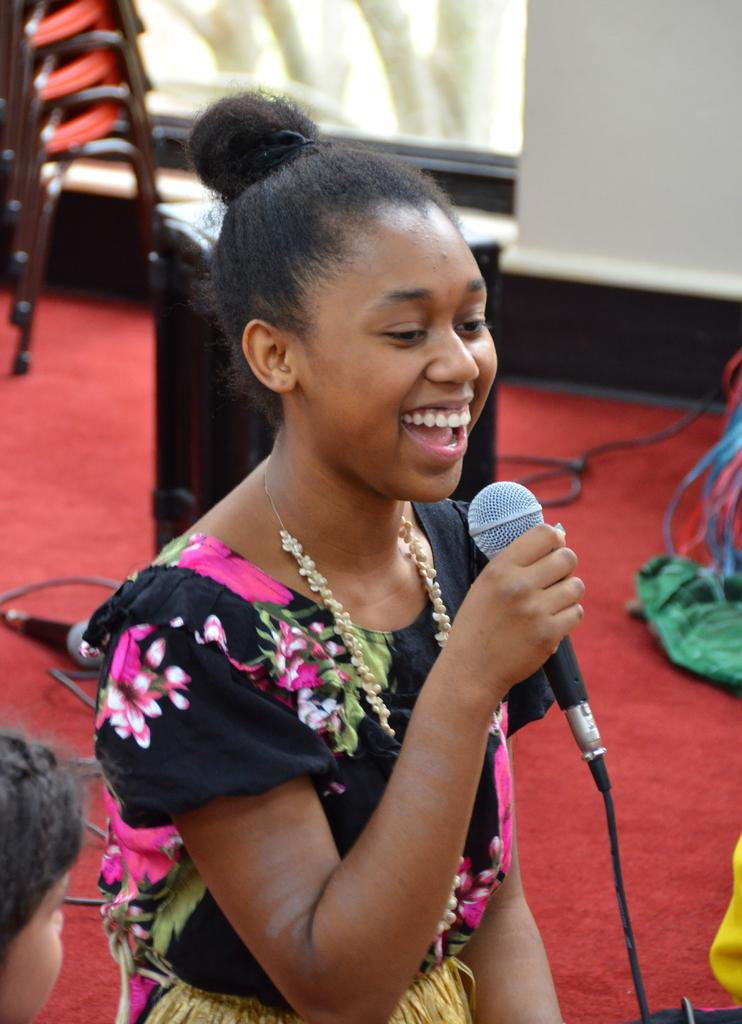What is the main subject of the image? The main subject of the image is a woman. What is the woman holding in her hand? The woman is holding a mic in her hand. What grade did the woman receive for her performance in the image? There is no indication of a performance or grade in the image, as it only shows a woman holding a mic. 